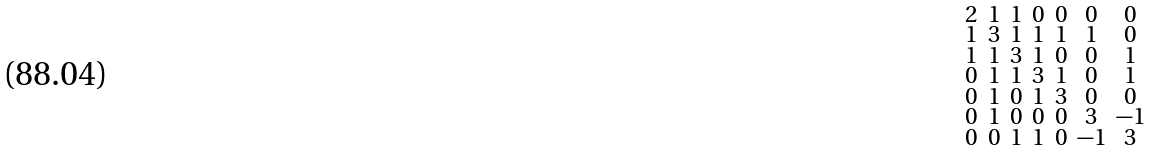<formula> <loc_0><loc_0><loc_500><loc_500>\begin{smallmatrix} 2 & 1 & 1 & 0 & 0 & 0 & 0 \\ 1 & 3 & 1 & 1 & 1 & 1 & 0 \\ 1 & 1 & 3 & 1 & 0 & 0 & 1 \\ 0 & 1 & 1 & 3 & 1 & 0 & 1 \\ 0 & 1 & 0 & 1 & 3 & 0 & 0 \\ 0 & 1 & 0 & 0 & 0 & 3 & - 1 \\ 0 & 0 & 1 & 1 & 0 & - 1 & 3 \end{smallmatrix}</formula> 